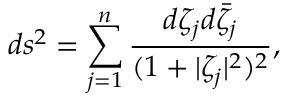<formula> <loc_0><loc_0><loc_500><loc_500>d s ^ { 2 } = \sum _ { j = 1 } ^ { n } \frac { d \zeta _ { j } d \bar { \zeta } _ { j } } { ( 1 + | \zeta _ { j } | ^ { 2 } ) ^ { 2 } } ,</formula> 